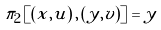<formula> <loc_0><loc_0><loc_500><loc_500>\pi _ { 2 } \left [ \left ( x , u \right ) , \left ( y , v \right ) \right ] = y</formula> 